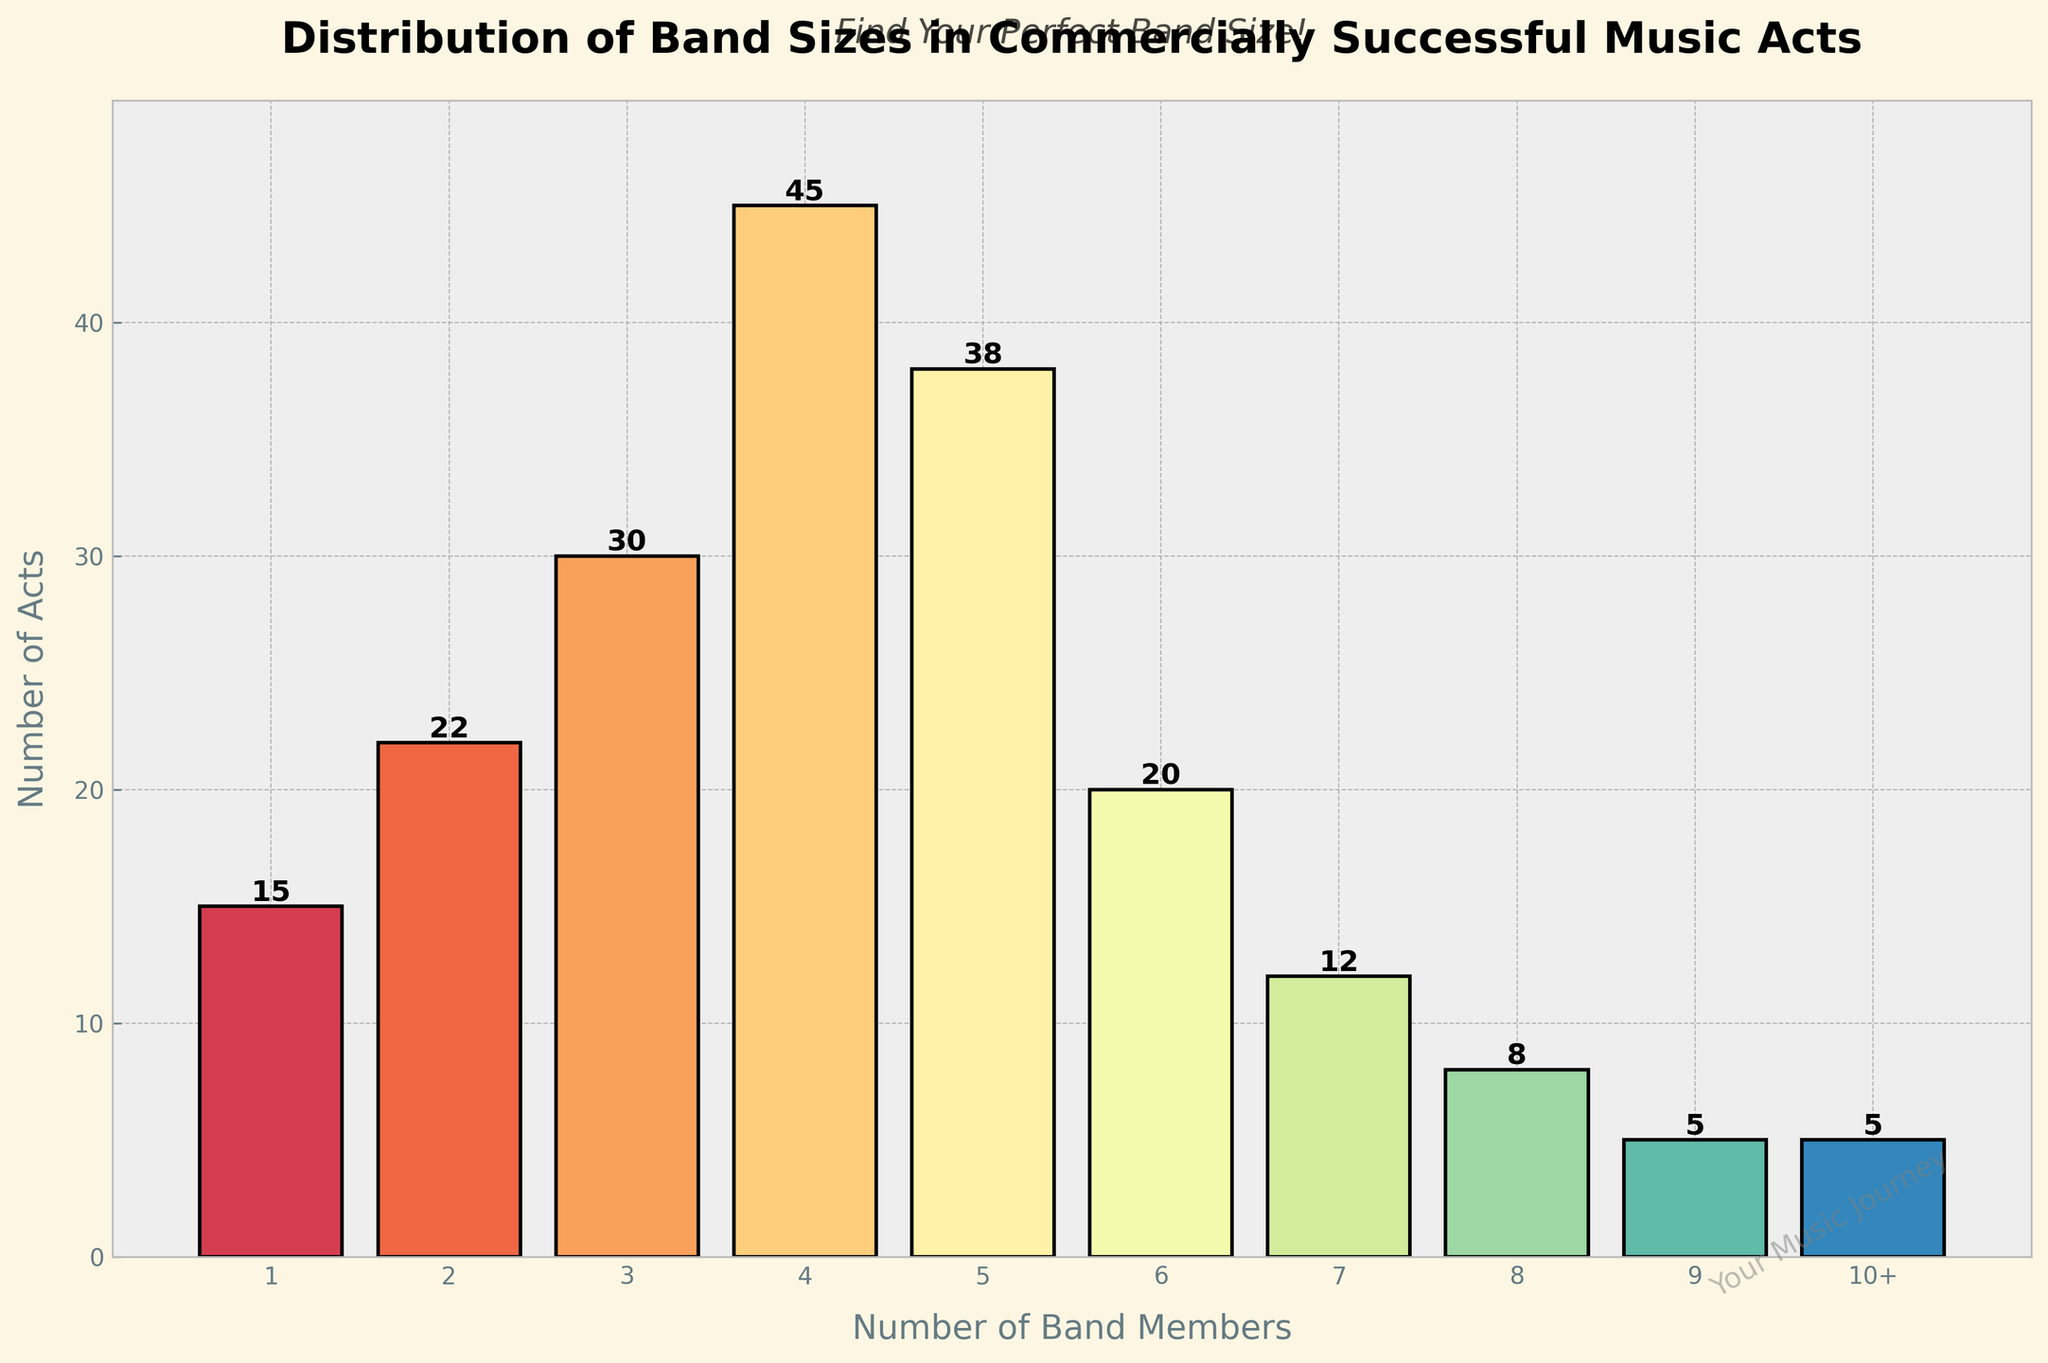Which band size has the highest number of commercially successful acts? The figure shows the number of acts for each band size as bars. The tallest bar represents the band size with the highest number of acts. The tallest bar appears at the band size of 4, indicating it has the highest number of commercially successful acts.
Answer: 4 How many bands have more than 5 members? To find the number of bands with more than 5 members, identify the bars representing band sizes of 6, 7, 8, 9, and 10+, and sum the number of acts for these sizes. The bands with 6, 7, 8, 9, and 10+ members have 20, 12, 8, 5, and 5 acts, respectively. The total is 20 + 12 + 8 + 5 + 5 = 50.
Answer: 50 Which band size has the least number of commercially successful acts? The shortest bar in the histogram indicates the band size with the least number of acts. The shortest bar appears at the band sizes of 9 and 10+, each with 5 acts.
Answer: 9 and 10+ How many acts feature 3 to 5 members? To determine the number of acts with band sizes of 3, 4, and 5 members, sum the acts for these sizes. The bands with 3, 4, and 5 members have 30, 45, and 38 acts, respectively. The total is 30 + 45 + 38 = 113.
Answer: 113 What percentage of the total commercially successful acts are bands of 4 members? First, sum the total number of all acts. The total is 15 + 22 + 30 + 45 + 38 + 20 + 12 + 8 + 5 + 5 = 200 acts. The number of 4-member bands is 45. Then calculate the percentage: (45 / 200) * 100 ≈ 22.5%.
Answer: 22.5% How does the number of 2-member bands compare to the number of 1-member bands? The bar for 1-member bands shows 15 acts, and the bar for 2-member bands shows 22 acts. Comparing these, 2-member bands have more acts than 1-member bands.
Answer: 2-member bands have more acts Is there a significant drop in the number of bands after a specific band size? By looking at the histogram, notice a sharp decline after the 6-member bands. The 6-member bands have 20 acts and the number drops significantly for 7-member bands with 12 acts and continues to decline.
Answer: Yes, after 6 members How many more commercially successful 5-member bands are there than 6-member bands? From the histogram, the number of 5-member bands is 38 and the number of 6-member bands is 20. The difference is 38 - 20 = 18.
Answer: 18 Which band size is twice as common as the 8-member bands? The histogram shows 8-member bands have 8 acts. Twice this number is 16. The closest size with approximately 16 acts is the 2-member bands which have 22 acts, more than 16. Thus, no band size exactly has double the number of 8-member bands.
Answer: None What trend do you observe in the distribution of bands with increasing members? The trend indicated by the histogram shows that the number of commercially successful bands increases from 1-member bands, peaks at 4-member bands, and then generally decreases as the number of members increases.
Answer: Increases up to 4 members, then decreases 